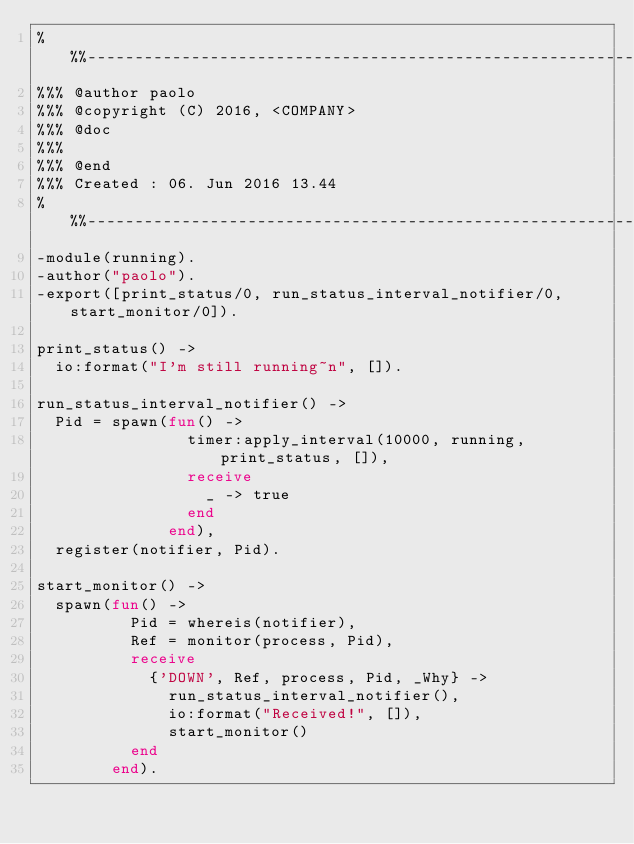<code> <loc_0><loc_0><loc_500><loc_500><_Erlang_>%%%-------------------------------------------------------------------
%%% @author paolo
%%% @copyright (C) 2016, <COMPANY>
%%% @doc
%%%
%%% @end
%%% Created : 06. Jun 2016 13.44
%%%-------------------------------------------------------------------
-module(running).
-author("paolo").
-export([print_status/0, run_status_interval_notifier/0, start_monitor/0]).

print_status() ->
  io:format("I'm still running~n", []).

run_status_interval_notifier() ->
  Pid = spawn(fun() ->
                timer:apply_interval(10000, running, print_status, []),
                receive
                  _ -> true
                end
              end),
  register(notifier, Pid).

start_monitor() ->
  spawn(fun() ->
          Pid = whereis(notifier),
          Ref = monitor(process, Pid),
          receive
            {'DOWN', Ref, process, Pid, _Why} ->
              run_status_interval_notifier(),
              io:format("Received!", []),
              start_monitor()
          end
        end).



</code> 